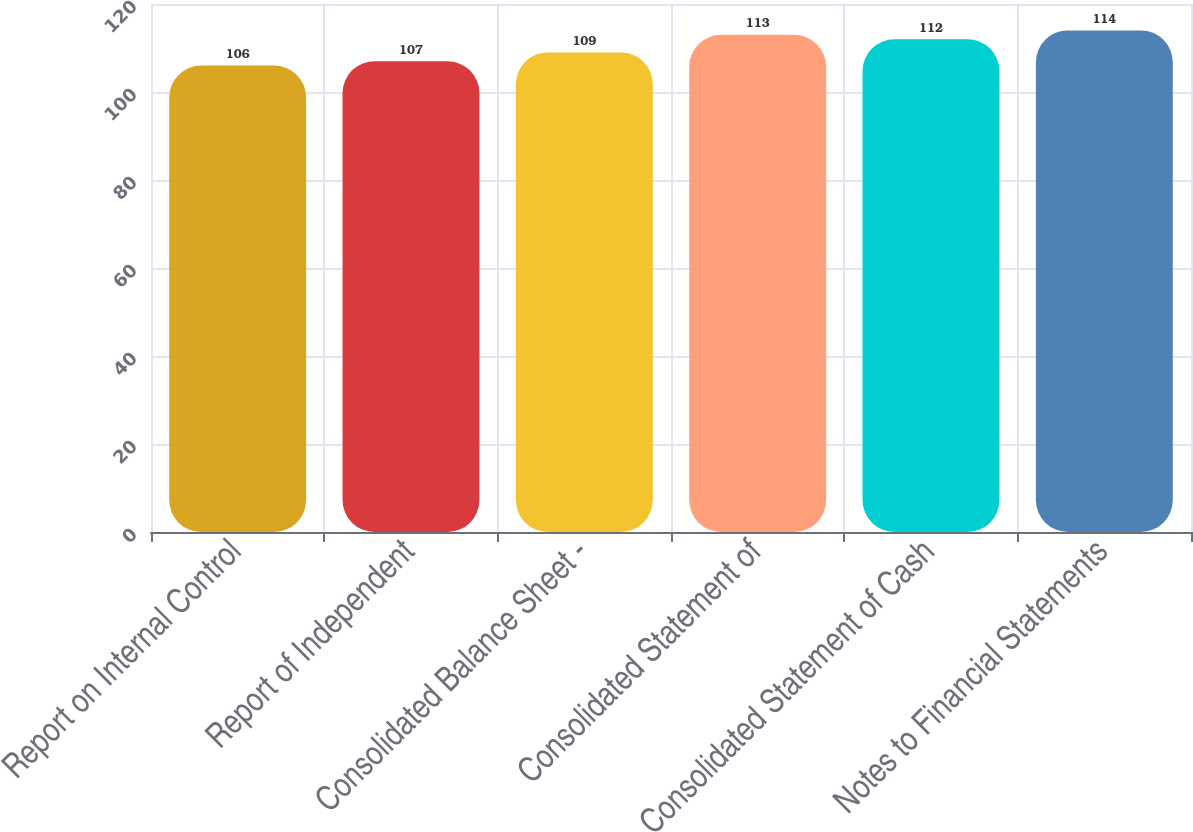<chart> <loc_0><loc_0><loc_500><loc_500><bar_chart><fcel>Report on Internal Control<fcel>Report of Independent<fcel>Consolidated Balance Sheet -<fcel>Consolidated Statement of<fcel>Consolidated Statement of Cash<fcel>Notes to Financial Statements<nl><fcel>106<fcel>107<fcel>109<fcel>113<fcel>112<fcel>114<nl></chart> 